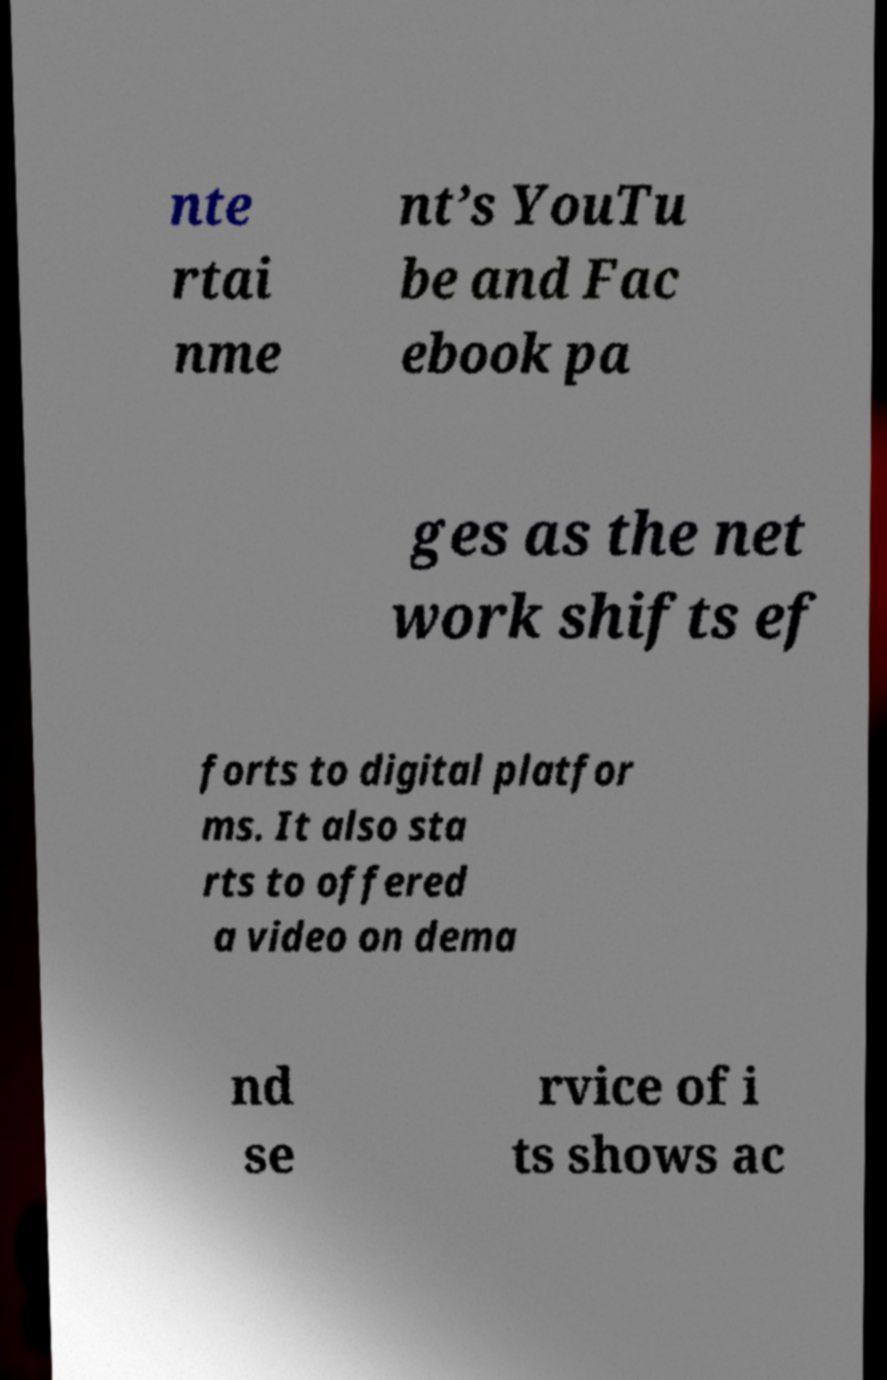Please read and relay the text visible in this image. What does it say? nte rtai nme nt’s YouTu be and Fac ebook pa ges as the net work shifts ef forts to digital platfor ms. It also sta rts to offered a video on dema nd se rvice of i ts shows ac 